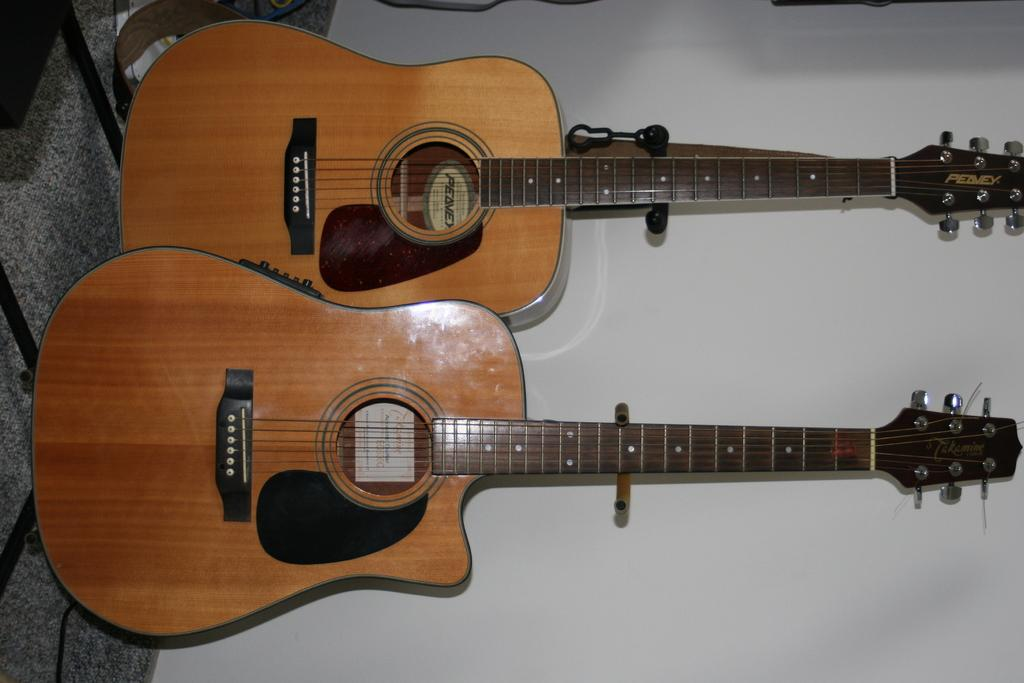What musical instruments are present in the image? There are two guitars in the image. What is the color of the wall in the image? The wall in the image is white-colored. What type of voyage is depicted in the image? There is no voyage depicted in the image; it features two guitars and a white-colored wall. Can you see any fangs in the image? There are no fangs present in the image. 